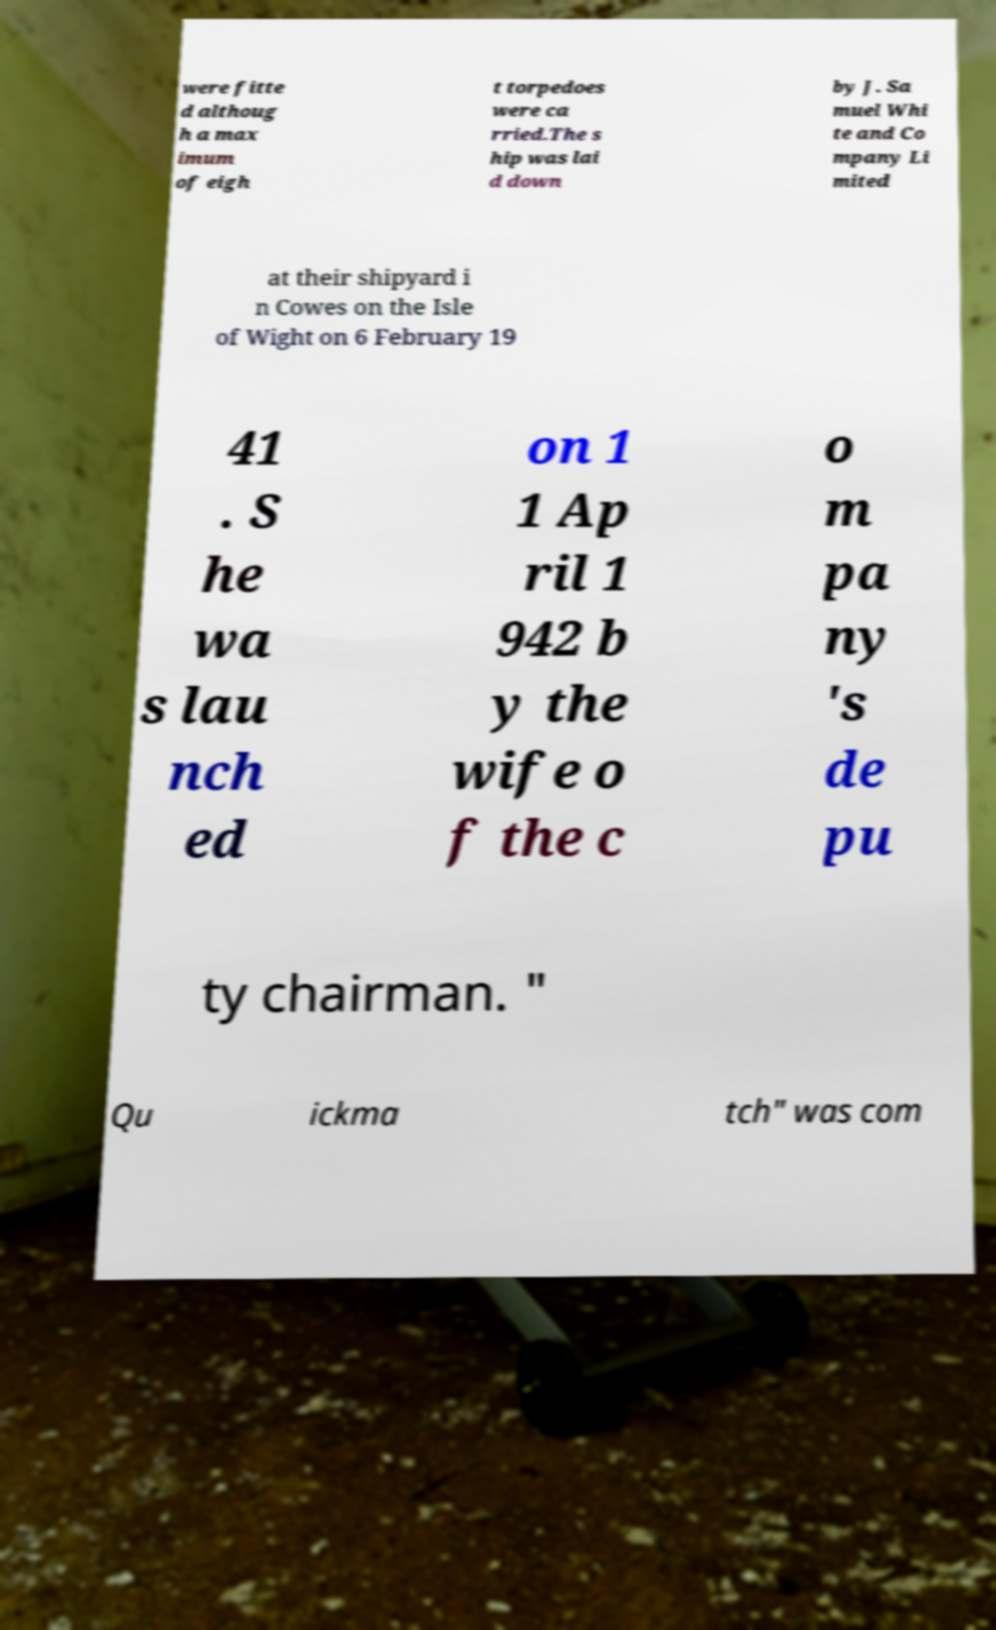Could you extract and type out the text from this image? were fitte d althoug h a max imum of eigh t torpedoes were ca rried.The s hip was lai d down by J. Sa muel Whi te and Co mpany Li mited at their shipyard i n Cowes on the Isle of Wight on 6 February 19 41 . S he wa s lau nch ed on 1 1 Ap ril 1 942 b y the wife o f the c o m pa ny 's de pu ty chairman. " Qu ickma tch" was com 